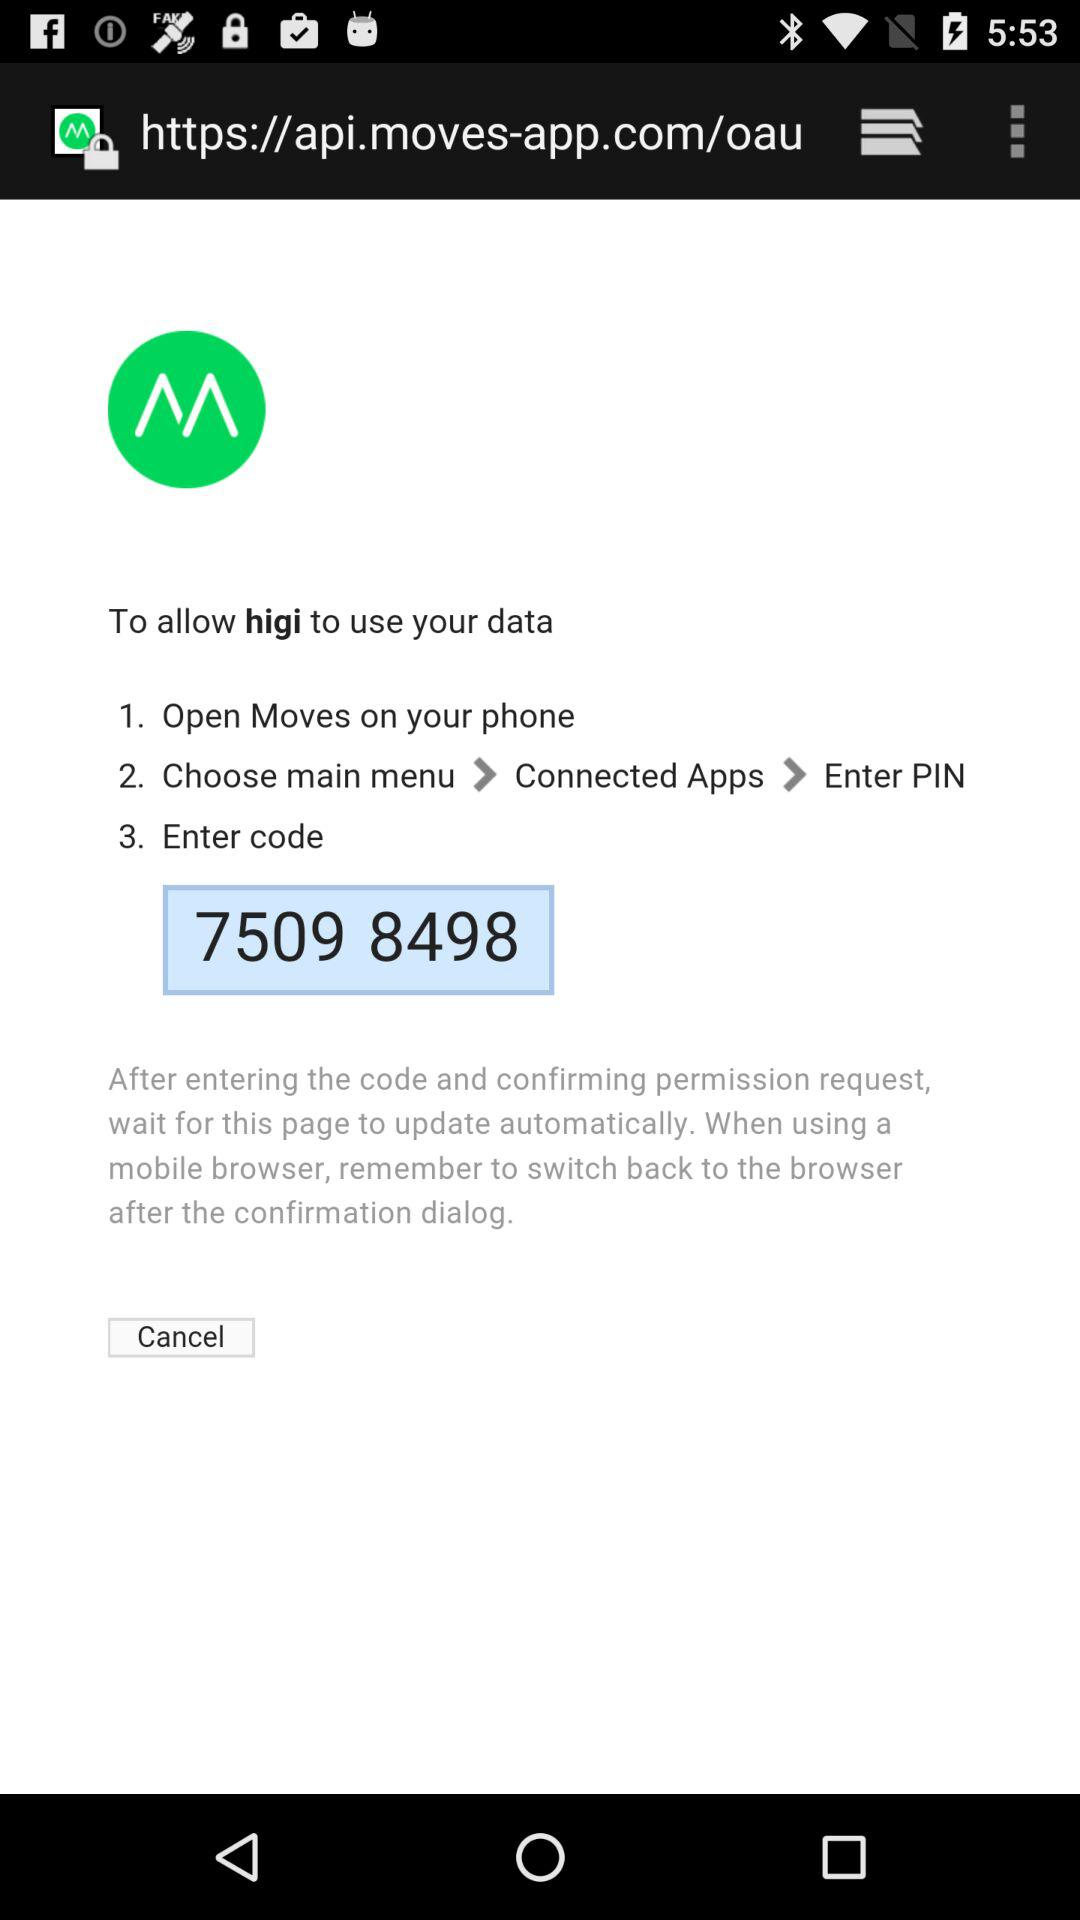How many steps are there in the instructions?
Answer the question using a single word or phrase. 3 